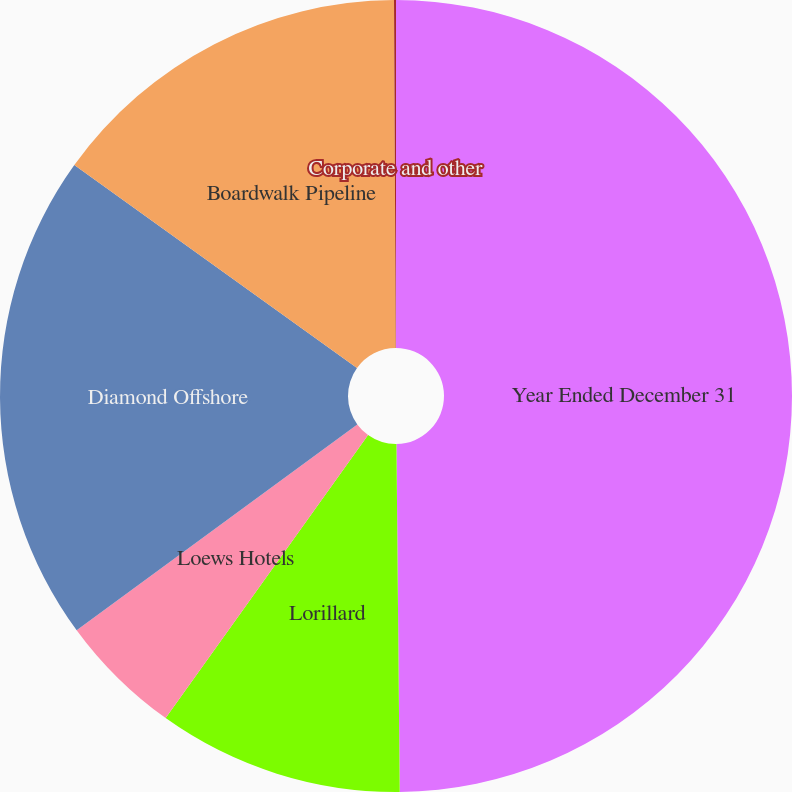Convert chart to OTSL. <chart><loc_0><loc_0><loc_500><loc_500><pie_chart><fcel>Year Ended December 31<fcel>Lorillard<fcel>Loews Hotels<fcel>Diamond Offshore<fcel>Boardwalk Pipeline<fcel>Corporate and other<nl><fcel>49.85%<fcel>10.03%<fcel>5.05%<fcel>19.98%<fcel>15.01%<fcel>0.08%<nl></chart> 